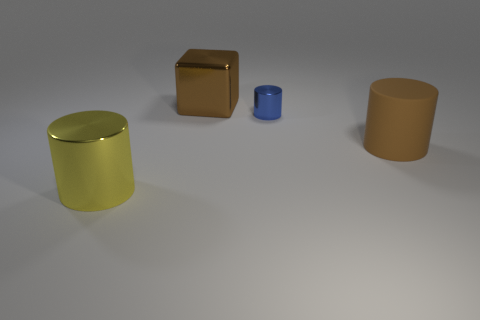Subtract all yellow shiny cylinders. How many cylinders are left? 2 Subtract 3 cylinders. How many cylinders are left? 0 Add 4 large purple rubber balls. How many objects exist? 8 Subtract all yellow cylinders. How many cylinders are left? 2 Subtract all purple blocks. Subtract all purple cylinders. How many blocks are left? 1 Subtract all blue cubes. How many cyan cylinders are left? 0 Subtract all brown metallic objects. Subtract all cylinders. How many objects are left? 0 Add 1 big brown objects. How many big brown objects are left? 3 Add 3 cyan rubber cylinders. How many cyan rubber cylinders exist? 3 Subtract 0 purple spheres. How many objects are left? 4 